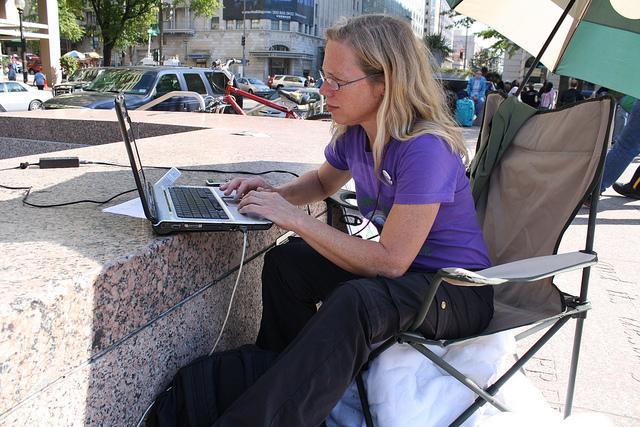Why is she working here?

Choices:
A) left home
B) sunny outside
C) power source
D) is hiding power source 